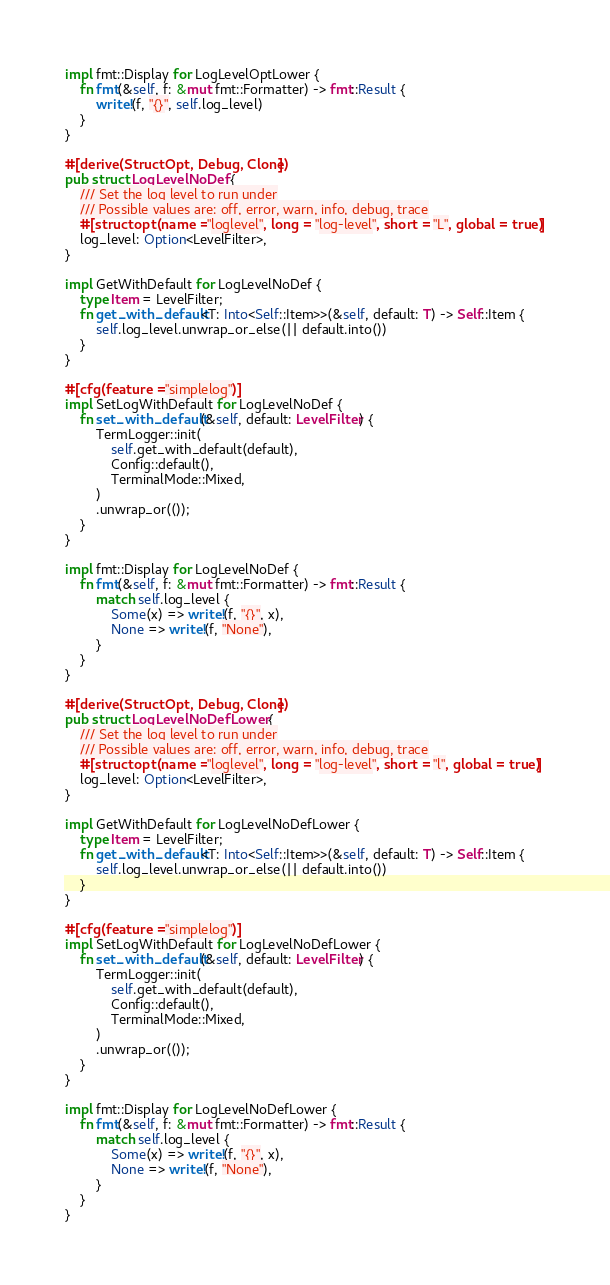Convert code to text. <code><loc_0><loc_0><loc_500><loc_500><_Rust_>
impl fmt::Display for LogLevelOptLower {
    fn fmt(&self, f: &mut fmt::Formatter) -> fmt::Result {
        write!(f, "{}", self.log_level)
    }
}

#[derive(StructOpt, Debug, Clone)]
pub struct LogLevelNoDef {
    /// Set the log level to run under
    /// Possible values are: off, error, warn, info, debug, trace
    #[structopt(name = "loglevel", long = "log-level", short = "L", global = true)]
    log_level: Option<LevelFilter>,
}

impl GetWithDefault for LogLevelNoDef {
    type Item = LevelFilter;
    fn get_with_default<T: Into<Self::Item>>(&self, default: T) -> Self::Item {
        self.log_level.unwrap_or_else(|| default.into())
    }
}

#[cfg(feature = "simplelog")]
impl SetLogWithDefault for LogLevelNoDef {
    fn set_with_default(&self, default: LevelFilter) {
        TermLogger::init(
            self.get_with_default(default),
            Config::default(),
            TerminalMode::Mixed,
        )
        .unwrap_or(());
    }
}

impl fmt::Display for LogLevelNoDef {
    fn fmt(&self, f: &mut fmt::Formatter) -> fmt::Result {
        match self.log_level {
            Some(x) => write!(f, "{}", x),
            None => write!(f, "None"),
        }
    }
}

#[derive(StructOpt, Debug, Clone)]
pub struct LogLevelNoDefLower {
    /// Set the log level to run under
    /// Possible values are: off, error, warn, info, debug, trace
    #[structopt(name = "loglevel", long = "log-level", short = "l", global = true)]
    log_level: Option<LevelFilter>,
}

impl GetWithDefault for LogLevelNoDefLower {
    type Item = LevelFilter;
    fn get_with_default<T: Into<Self::Item>>(&self, default: T) -> Self::Item {
        self.log_level.unwrap_or_else(|| default.into())
    }
}

#[cfg(feature = "simplelog")]
impl SetLogWithDefault for LogLevelNoDefLower {
    fn set_with_default(&self, default: LevelFilter) {
        TermLogger::init(
            self.get_with_default(default),
            Config::default(),
            TerminalMode::Mixed,
        )
        .unwrap_or(());
    }
}

impl fmt::Display for LogLevelNoDefLower {
    fn fmt(&self, f: &mut fmt::Formatter) -> fmt::Result {
        match self.log_level {
            Some(x) => write!(f, "{}", x),
            None => write!(f, "None"),
        }
    }
}
</code> 